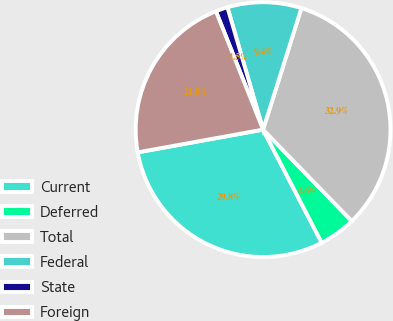Convert chart to OTSL. <chart><loc_0><loc_0><loc_500><loc_500><pie_chart><fcel>Current<fcel>Deferred<fcel>Total<fcel>Federal<fcel>State<fcel>Foreign<nl><fcel>29.76%<fcel>4.64%<fcel>32.88%<fcel>9.38%<fcel>1.52%<fcel>21.82%<nl></chart> 